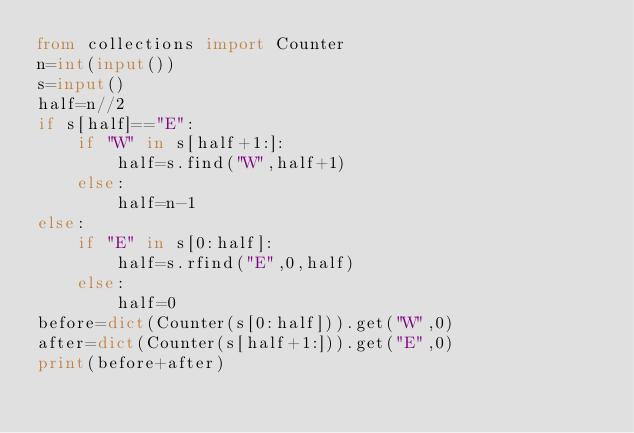<code> <loc_0><loc_0><loc_500><loc_500><_Python_>from collections import Counter
n=int(input())
s=input()
half=n//2
if s[half]=="E":
    if "W" in s[half+1:]:
        half=s.find("W",half+1)
    else:
        half=n-1
else:
    if "E" in s[0:half]:
        half=s.rfind("E",0,half)
    else:
        half=0
before=dict(Counter(s[0:half])).get("W",0)
after=dict(Counter(s[half+1:])).get("E",0)
print(before+after)</code> 